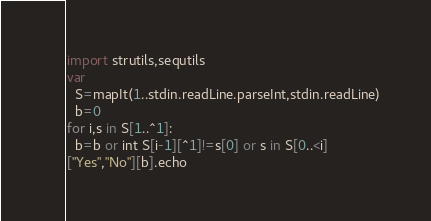<code> <loc_0><loc_0><loc_500><loc_500><_Nim_>import strutils,sequtils
var
  S=mapIt(1..stdin.readLine.parseInt,stdin.readLine)
  b=0
for i,s in S[1..^1]:
  b=b or int S[i-1][^1]!=s[0] or s in S[0..<i]
["Yes","No"][b].echo</code> 